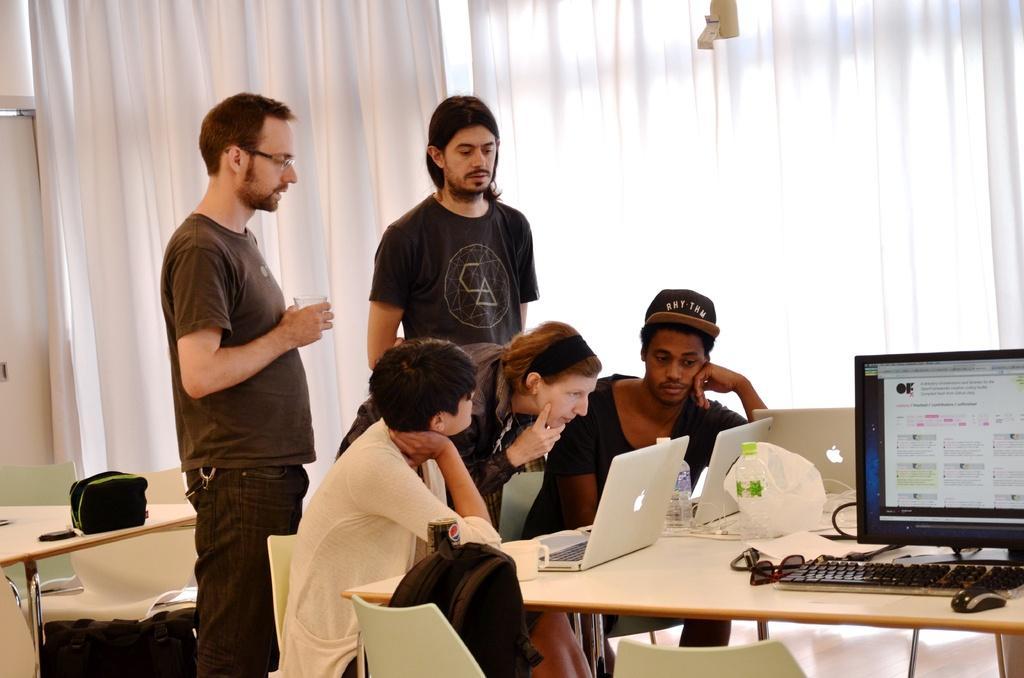Describe this image in one or two sentences. This picture describes about group of people, few are seated on the chair and few are standing, in front of them we can find laptops, couple of bottles, plastic cover, monitor, keyboard, mouse and spectacles on the table, and also we can find a tin and a bag besides to the seated person, in the background we can see curtains and a light. 